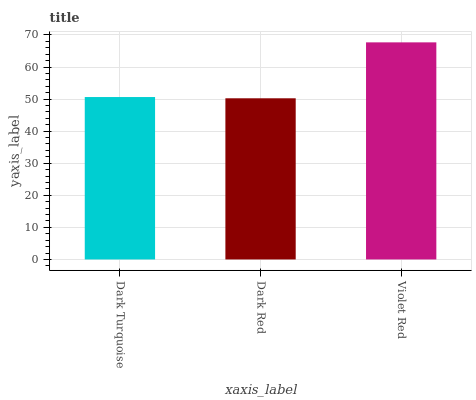Is Dark Red the minimum?
Answer yes or no. Yes. Is Violet Red the maximum?
Answer yes or no. Yes. Is Violet Red the minimum?
Answer yes or no. No. Is Dark Red the maximum?
Answer yes or no. No. Is Violet Red greater than Dark Red?
Answer yes or no. Yes. Is Dark Red less than Violet Red?
Answer yes or no. Yes. Is Dark Red greater than Violet Red?
Answer yes or no. No. Is Violet Red less than Dark Red?
Answer yes or no. No. Is Dark Turquoise the high median?
Answer yes or no. Yes. Is Dark Turquoise the low median?
Answer yes or no. Yes. Is Dark Red the high median?
Answer yes or no. No. Is Dark Red the low median?
Answer yes or no. No. 